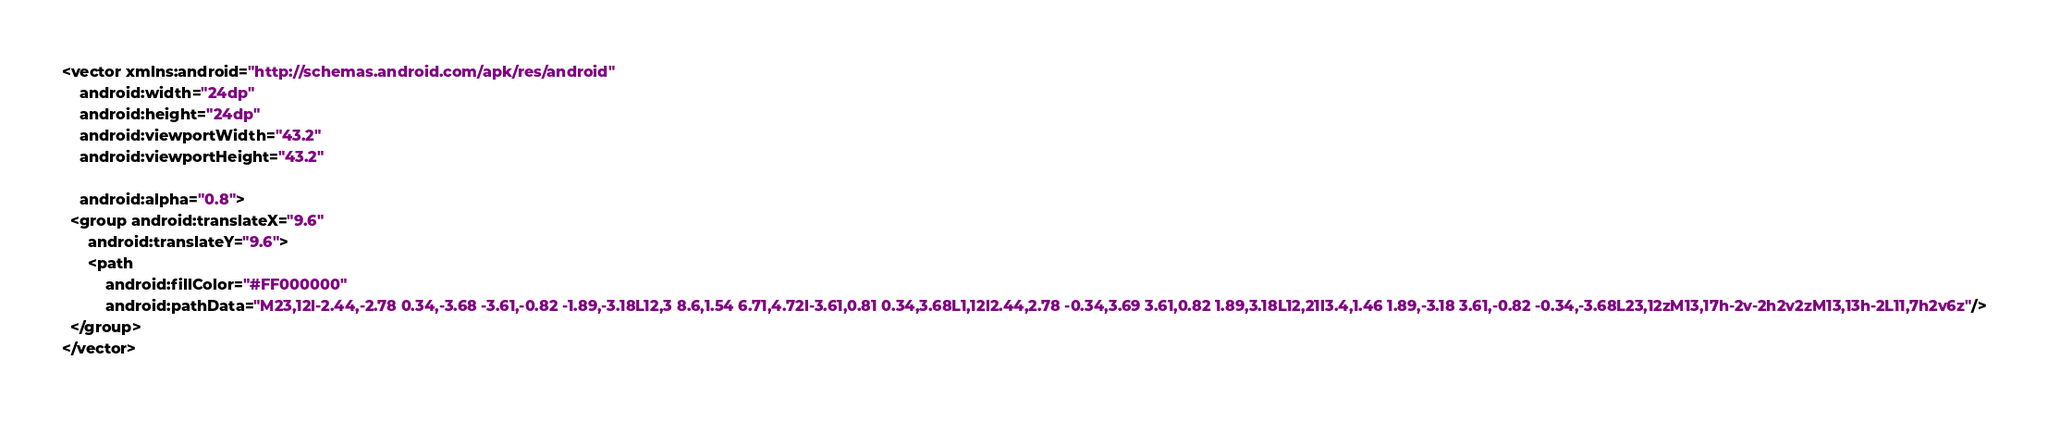<code> <loc_0><loc_0><loc_500><loc_500><_XML_><vector xmlns:android="http://schemas.android.com/apk/res/android"
    android:width="24dp"
    android:height="24dp"
    android:viewportWidth="43.2"
    android:viewportHeight="43.2"

    android:alpha="0.8">
  <group android:translateX="9.6"
      android:translateY="9.6">
      <path
          android:fillColor="#FF000000"
          android:pathData="M23,12l-2.44,-2.78 0.34,-3.68 -3.61,-0.82 -1.89,-3.18L12,3 8.6,1.54 6.71,4.72l-3.61,0.81 0.34,3.68L1,12l2.44,2.78 -0.34,3.69 3.61,0.82 1.89,3.18L12,21l3.4,1.46 1.89,-3.18 3.61,-0.82 -0.34,-3.68L23,12zM13,17h-2v-2h2v2zM13,13h-2L11,7h2v6z"/>
  </group>
</vector>
</code> 